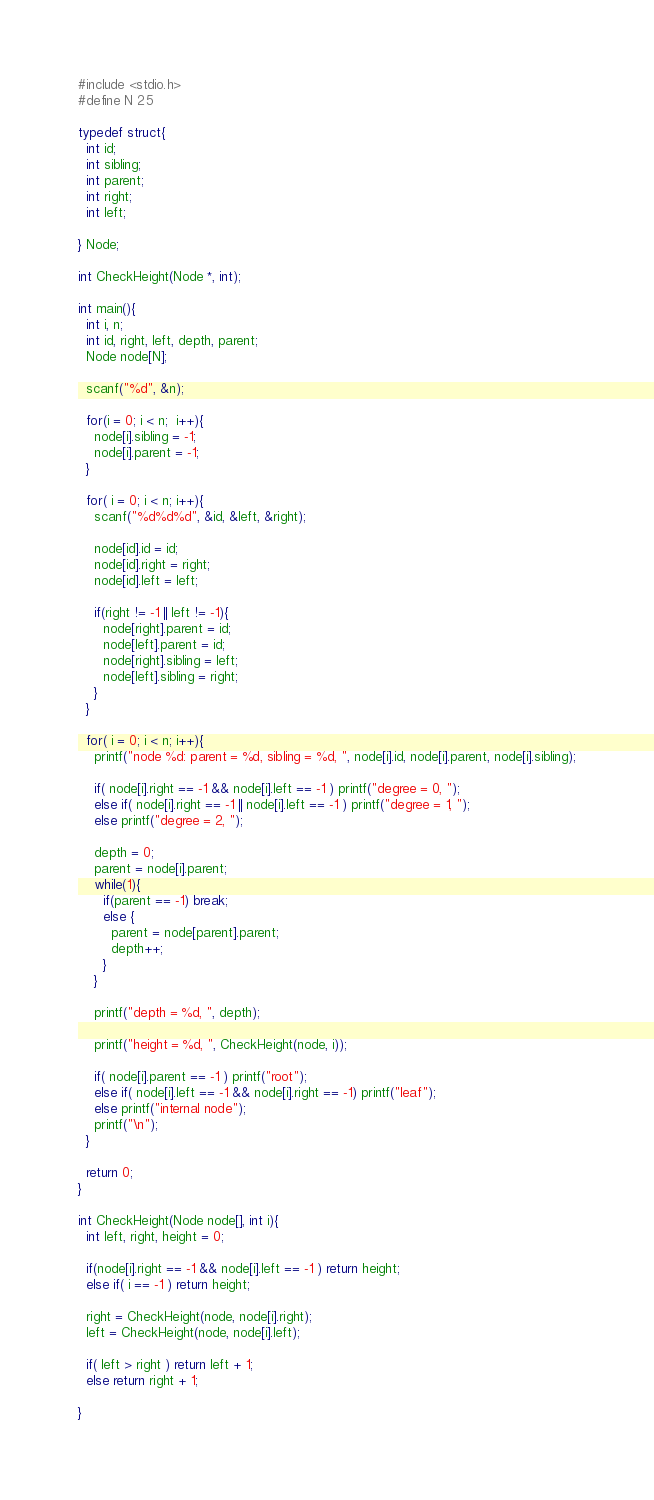<code> <loc_0><loc_0><loc_500><loc_500><_C_>#include <stdio.h>
#define N 25
 
typedef struct{
  int id;
  int sibling;
  int parent;
  int right;
  int left;

} Node;

int CheckHeight(Node *, int);

int main(){
  int i, n;
  int id, right, left, depth, parent;
  Node node[N];
 
  scanf("%d", &n);
 
  for(i = 0; i < n;  i++){
    node[i].sibling = -1;
    node[i].parent = -1;
  }
 
  for( i = 0; i < n; i++){
    scanf("%d%d%d", &id, &left, &right);
 
    node[id].id = id;
    node[id].right = right;
    node[id].left = left; 

    if(right != -1 || left != -1){
      node[right].parent = id;
      node[left].parent = id;
      node[right].sibling = left;
      node[left].sibling = right;
    }
  }
 
  for( i = 0; i < n; i++){
    printf("node %d: parent = %d, sibling = %d, ", node[i].id, node[i].parent, node[i].sibling);
 
    if( node[i].right == -1 && node[i].left == -1 ) printf("degree = 0, ");
    else if( node[i].right == -1 || node[i].left == -1 ) printf("degree = 1, ");
    else printf("degree = 2, ");
 
    depth = 0;
    parent = node[i].parent;
    while(1){
      if(parent == -1) break;
      else {
        parent = node[parent].parent;
        depth++;
      }
    }
 
    printf("depth = %d, ", depth);
 
    printf("height = %d, ", CheckHeight(node, i));
 
    if( node[i].parent == -1 ) printf("root");
    else if( node[i].left == -1 && node[i].right == -1) printf("leaf");
    else printf("internal node");
    printf("\n");
  }
 
  return 0;
} 

int CheckHeight(Node node[], int i){
  int left, right, height = 0;
 
  if(node[i].right == -1 && node[i].left == -1 ) return height;
  else if( i == -1 ) return height;

  right = CheckHeight(node, node[i].right); 
  left = CheckHeight(node, node[i].left);

  if( left > right ) return left + 1;
  else return right + 1;
 
}</code> 